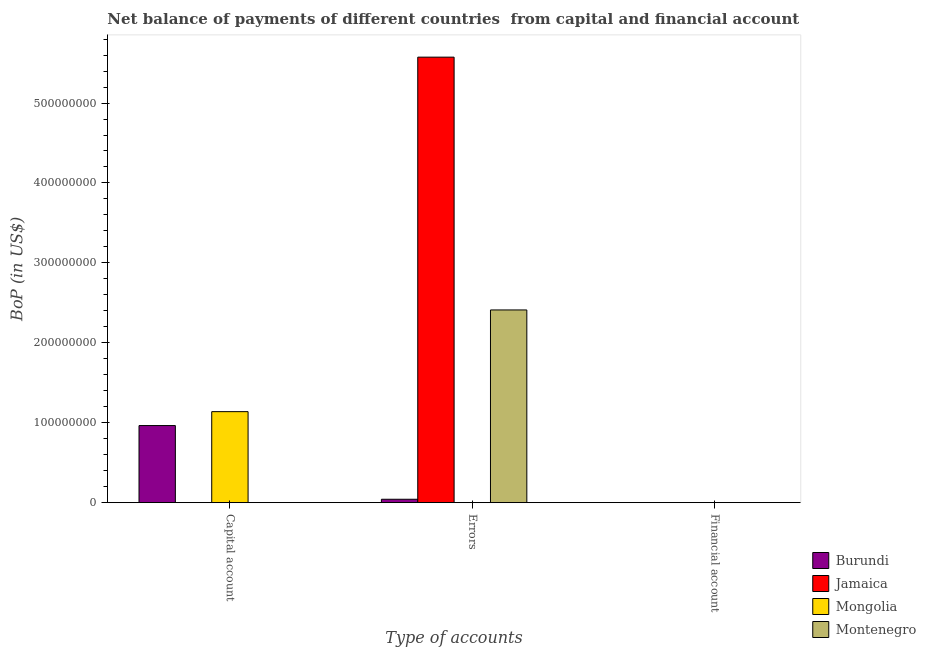Are the number of bars per tick equal to the number of legend labels?
Your response must be concise. No. Are the number of bars on each tick of the X-axis equal?
Provide a succinct answer. No. How many bars are there on the 3rd tick from the left?
Your answer should be very brief. 0. How many bars are there on the 2nd tick from the right?
Provide a short and direct response. 3. What is the label of the 3rd group of bars from the left?
Ensure brevity in your answer.  Financial account. Across all countries, what is the maximum amount of net capital account?
Your answer should be very brief. 1.14e+08. In which country was the amount of net capital account maximum?
Keep it short and to the point. Mongolia. What is the difference between the amount of net capital account in Mongolia and that in Burundi?
Ensure brevity in your answer.  1.74e+07. What is the difference between the amount of financial account in Burundi and the amount of net capital account in Jamaica?
Give a very brief answer. 0. What is the average amount of net capital account per country?
Provide a short and direct response. 5.26e+07. What is the difference between the amount of errors and amount of net capital account in Burundi?
Provide a succinct answer. -9.22e+07. What is the ratio of the amount of errors in Montenegro to that in Burundi?
Your answer should be very brief. 56.78. Is the amount of net capital account in Mongolia less than that in Burundi?
Offer a very short reply. No. What is the difference between the highest and the lowest amount of errors?
Make the answer very short. 5.57e+08. Is it the case that in every country, the sum of the amount of net capital account and amount of errors is greater than the amount of financial account?
Make the answer very short. Yes. Are the values on the major ticks of Y-axis written in scientific E-notation?
Give a very brief answer. No. Where does the legend appear in the graph?
Give a very brief answer. Bottom right. What is the title of the graph?
Your response must be concise. Net balance of payments of different countries  from capital and financial account. Does "Kyrgyz Republic" appear as one of the legend labels in the graph?
Give a very brief answer. No. What is the label or title of the X-axis?
Offer a very short reply. Type of accounts. What is the label or title of the Y-axis?
Give a very brief answer. BoP (in US$). What is the BoP (in US$) of Burundi in Capital account?
Ensure brevity in your answer.  9.65e+07. What is the BoP (in US$) of Mongolia in Capital account?
Offer a terse response. 1.14e+08. What is the BoP (in US$) in Burundi in Errors?
Ensure brevity in your answer.  4.25e+06. What is the BoP (in US$) in Jamaica in Errors?
Your answer should be very brief. 5.57e+08. What is the BoP (in US$) of Mongolia in Errors?
Ensure brevity in your answer.  0. What is the BoP (in US$) of Montenegro in Errors?
Your answer should be very brief. 2.41e+08. What is the BoP (in US$) of Burundi in Financial account?
Provide a succinct answer. 0. What is the BoP (in US$) in Mongolia in Financial account?
Provide a short and direct response. 0. What is the BoP (in US$) in Montenegro in Financial account?
Provide a succinct answer. 0. Across all Type of accounts, what is the maximum BoP (in US$) in Burundi?
Give a very brief answer. 9.65e+07. Across all Type of accounts, what is the maximum BoP (in US$) of Jamaica?
Ensure brevity in your answer.  5.57e+08. Across all Type of accounts, what is the maximum BoP (in US$) in Mongolia?
Offer a very short reply. 1.14e+08. Across all Type of accounts, what is the maximum BoP (in US$) in Montenegro?
Ensure brevity in your answer.  2.41e+08. Across all Type of accounts, what is the minimum BoP (in US$) in Montenegro?
Offer a very short reply. 0. What is the total BoP (in US$) of Burundi in the graph?
Offer a terse response. 1.01e+08. What is the total BoP (in US$) in Jamaica in the graph?
Ensure brevity in your answer.  5.57e+08. What is the total BoP (in US$) of Mongolia in the graph?
Provide a succinct answer. 1.14e+08. What is the total BoP (in US$) of Montenegro in the graph?
Your answer should be very brief. 2.41e+08. What is the difference between the BoP (in US$) in Burundi in Capital account and that in Errors?
Give a very brief answer. 9.22e+07. What is the difference between the BoP (in US$) of Burundi in Capital account and the BoP (in US$) of Jamaica in Errors?
Provide a short and direct response. -4.61e+08. What is the difference between the BoP (in US$) in Burundi in Capital account and the BoP (in US$) in Montenegro in Errors?
Ensure brevity in your answer.  -1.45e+08. What is the difference between the BoP (in US$) of Mongolia in Capital account and the BoP (in US$) of Montenegro in Errors?
Provide a short and direct response. -1.27e+08. What is the average BoP (in US$) of Burundi per Type of accounts?
Your response must be concise. 3.36e+07. What is the average BoP (in US$) of Jamaica per Type of accounts?
Provide a short and direct response. 1.86e+08. What is the average BoP (in US$) in Mongolia per Type of accounts?
Keep it short and to the point. 3.80e+07. What is the average BoP (in US$) in Montenegro per Type of accounts?
Your response must be concise. 8.04e+07. What is the difference between the BoP (in US$) of Burundi and BoP (in US$) of Mongolia in Capital account?
Provide a succinct answer. -1.74e+07. What is the difference between the BoP (in US$) in Burundi and BoP (in US$) in Jamaica in Errors?
Provide a succinct answer. -5.53e+08. What is the difference between the BoP (in US$) in Burundi and BoP (in US$) in Montenegro in Errors?
Provide a succinct answer. -2.37e+08. What is the difference between the BoP (in US$) in Jamaica and BoP (in US$) in Montenegro in Errors?
Make the answer very short. 3.16e+08. What is the ratio of the BoP (in US$) of Burundi in Capital account to that in Errors?
Provide a succinct answer. 22.72. What is the difference between the highest and the lowest BoP (in US$) in Burundi?
Your response must be concise. 9.65e+07. What is the difference between the highest and the lowest BoP (in US$) in Jamaica?
Ensure brevity in your answer.  5.57e+08. What is the difference between the highest and the lowest BoP (in US$) of Mongolia?
Give a very brief answer. 1.14e+08. What is the difference between the highest and the lowest BoP (in US$) in Montenegro?
Give a very brief answer. 2.41e+08. 